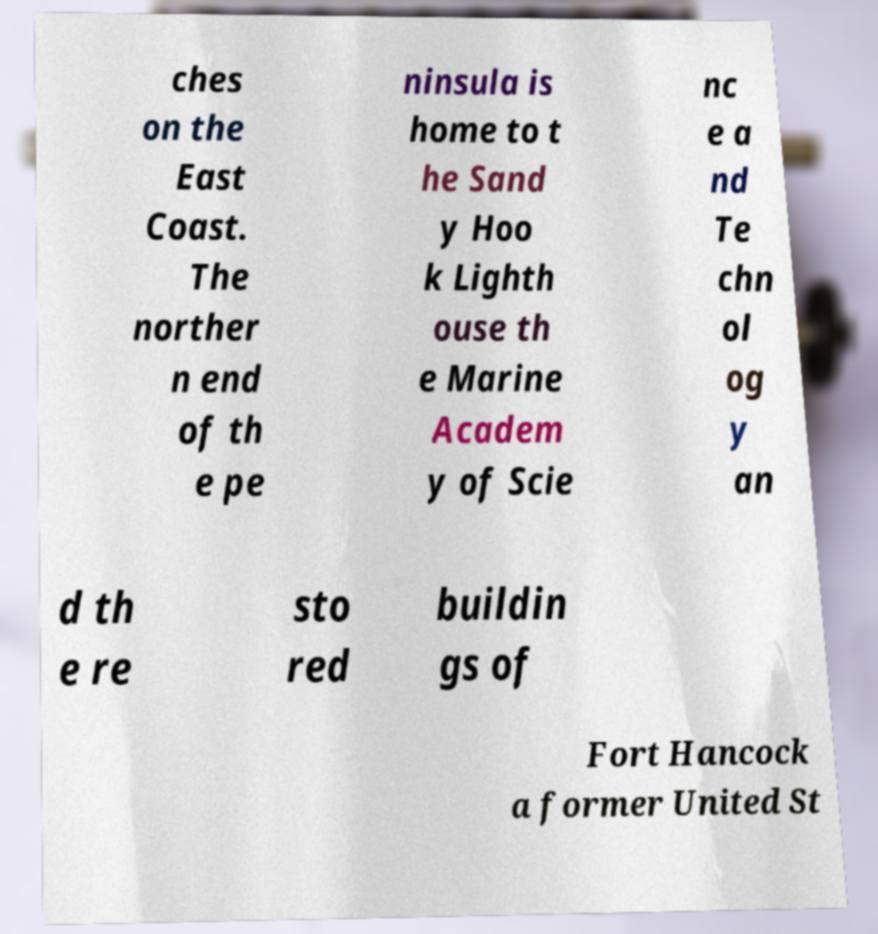Can you accurately transcribe the text from the provided image for me? ches on the East Coast. The norther n end of th e pe ninsula is home to t he Sand y Hoo k Lighth ouse th e Marine Academ y of Scie nc e a nd Te chn ol og y an d th e re sto red buildin gs of Fort Hancock a former United St 